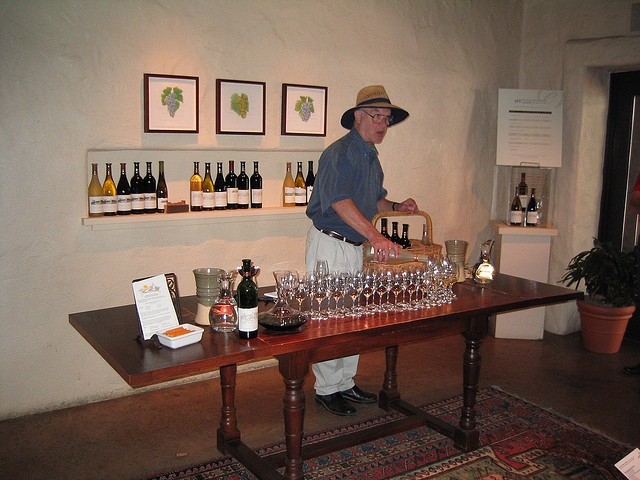Describe the objects in this image and their specific colors. I can see dining table in gray, maroon, black, and darkgray tones, people in gray, darkgray, and black tones, potted plant in gray, black, and maroon tones, bottle in gray, black, darkgray, and tan tones, and wine glass in gray, maroon, and darkgray tones in this image. 